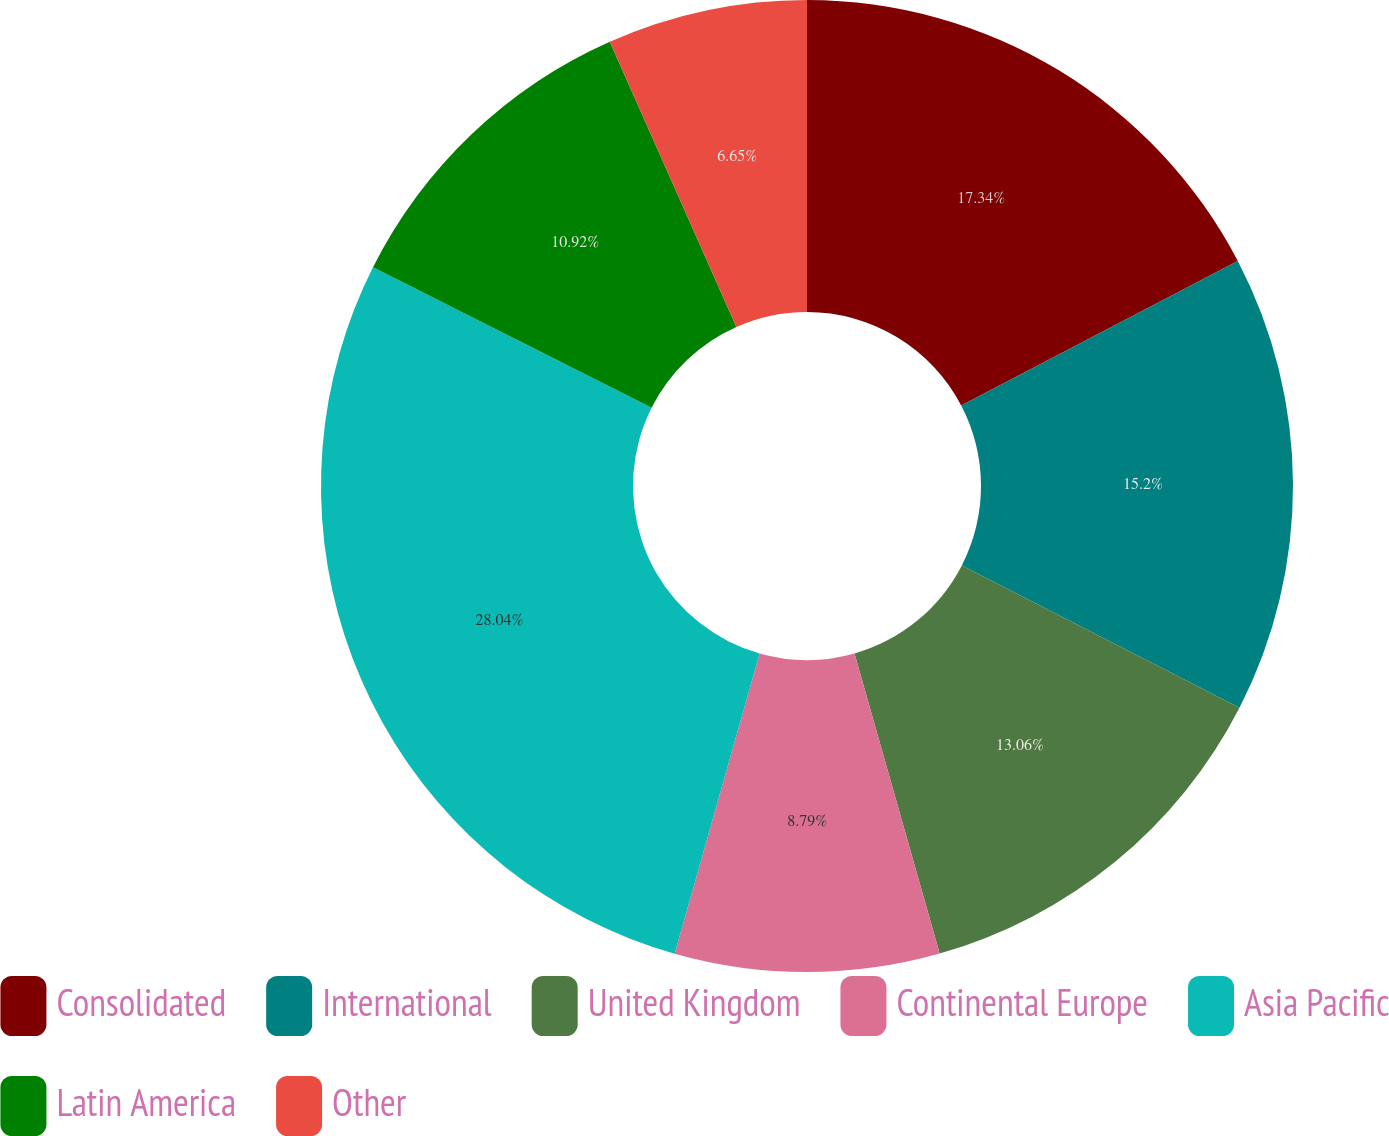<chart> <loc_0><loc_0><loc_500><loc_500><pie_chart><fcel>Consolidated<fcel>International<fcel>United Kingdom<fcel>Continental Europe<fcel>Asia Pacific<fcel>Latin America<fcel>Other<nl><fcel>17.34%<fcel>15.2%<fcel>13.06%<fcel>8.79%<fcel>28.04%<fcel>10.92%<fcel>6.65%<nl></chart> 